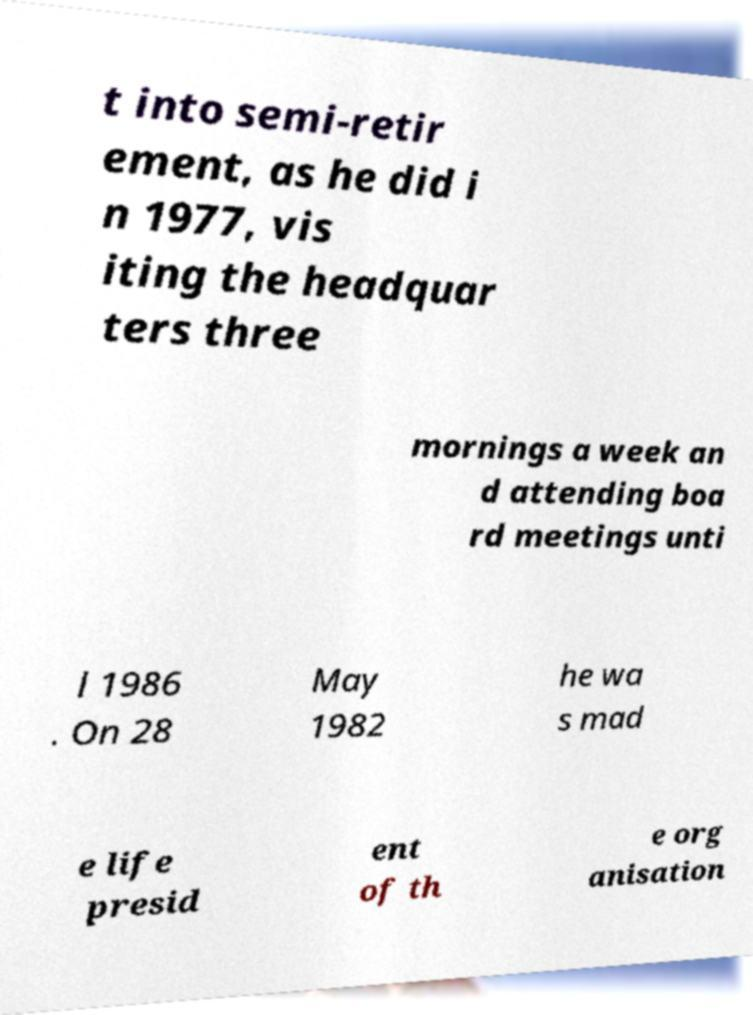Can you read and provide the text displayed in the image?This photo seems to have some interesting text. Can you extract and type it out for me? t into semi-retir ement, as he did i n 1977, vis iting the headquar ters three mornings a week an d attending boa rd meetings unti l 1986 . On 28 May 1982 he wa s mad e life presid ent of th e org anisation 